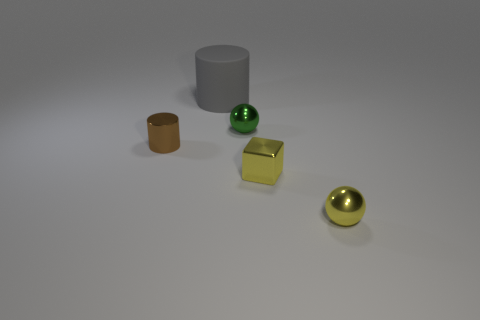Add 2 small cylinders. How many objects exist? 7 Subtract 0 purple cubes. How many objects are left? 5 Subtract all cubes. How many objects are left? 4 Subtract all large blue shiny cylinders. Subtract all gray objects. How many objects are left? 4 Add 3 tiny metal spheres. How many tiny metal spheres are left? 5 Add 4 red metallic spheres. How many red metallic spheres exist? 4 